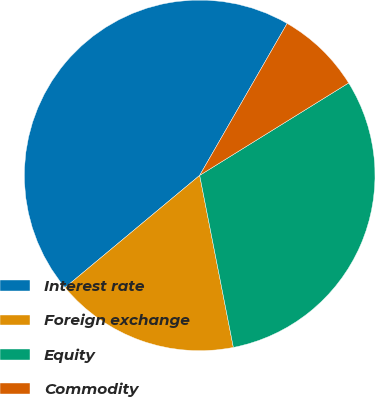<chart> <loc_0><loc_0><loc_500><loc_500><pie_chart><fcel>Interest rate<fcel>Foreign exchange<fcel>Equity<fcel>Commodity<nl><fcel>44.37%<fcel>17.02%<fcel>30.76%<fcel>7.85%<nl></chart> 